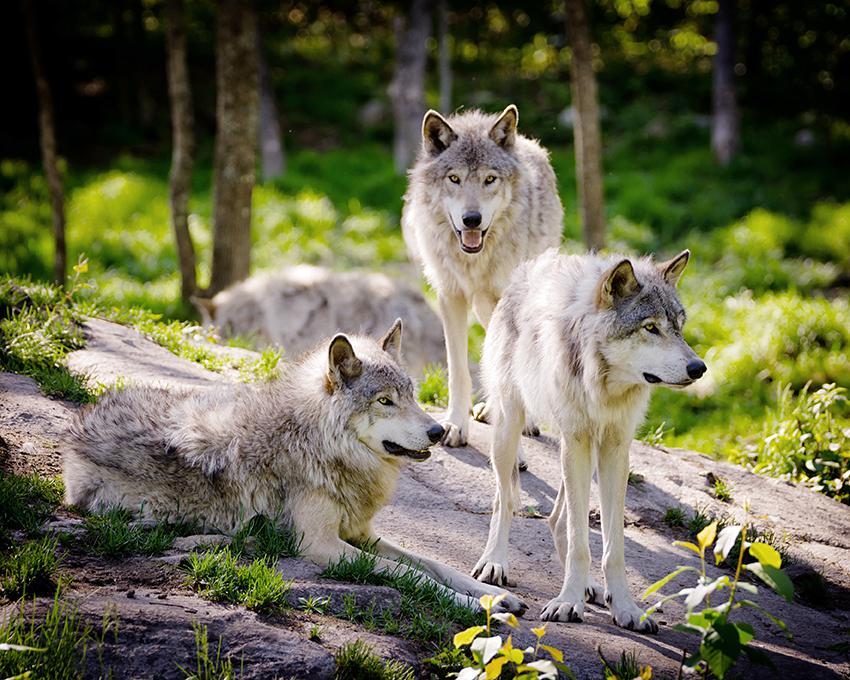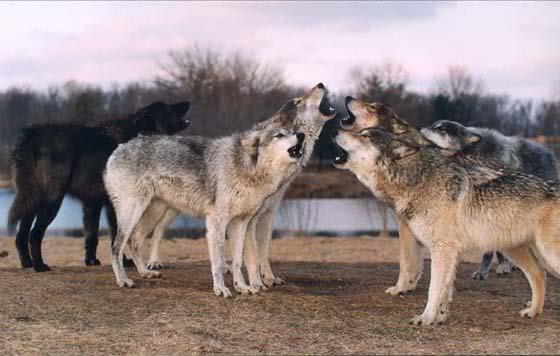The first image is the image on the left, the second image is the image on the right. Examine the images to the left and right. Is the description "There are two white dogs with blue packs in one image." accurate? Answer yes or no. No. The first image is the image on the left, the second image is the image on the right. Evaluate the accuracy of this statement regarding the images: "there are multiple dogs in blue backpacks". Is it true? Answer yes or no. No. 